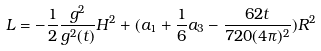<formula> <loc_0><loc_0><loc_500><loc_500>L = - \frac { 1 } { 2 } \frac { g ^ { 2 } } { g ^ { 2 } ( t ) } H ^ { 2 } + ( a _ { 1 } + \frac { 1 } { 6 } a _ { 3 } - \frac { 6 2 t } { 7 2 0 ( 4 \pi ) ^ { 2 } } ) R ^ { 2 }</formula> 